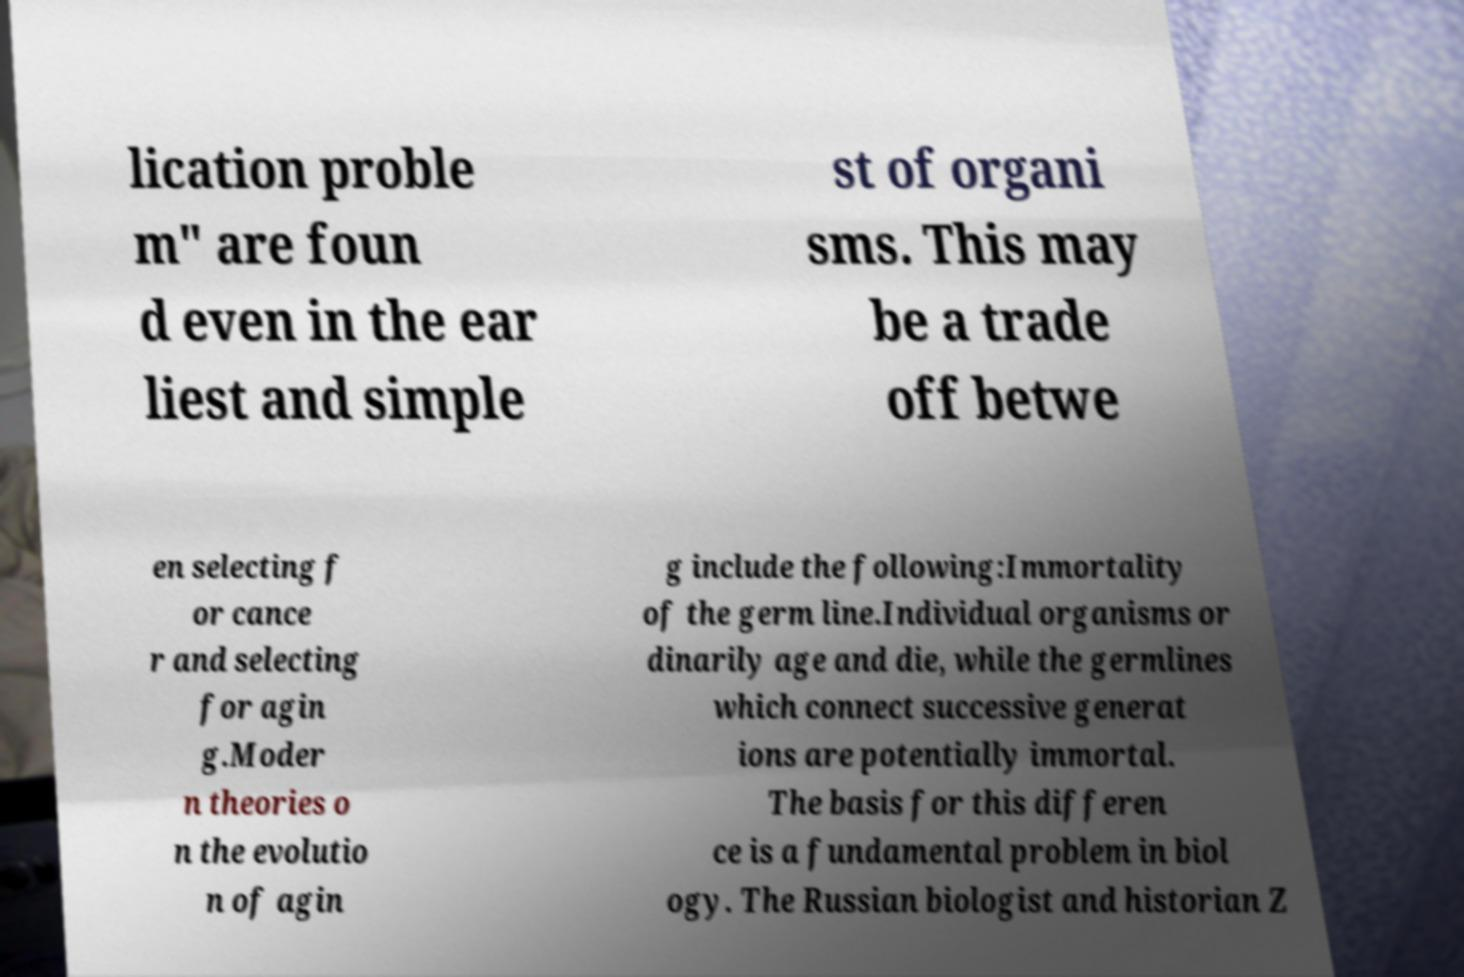Could you extract and type out the text from this image? lication proble m" are foun d even in the ear liest and simple st of organi sms. This may be a trade off betwe en selecting f or cance r and selecting for agin g.Moder n theories o n the evolutio n of agin g include the following:Immortality of the germ line.Individual organisms or dinarily age and die, while the germlines which connect successive generat ions are potentially immortal. The basis for this differen ce is a fundamental problem in biol ogy. The Russian biologist and historian Z 